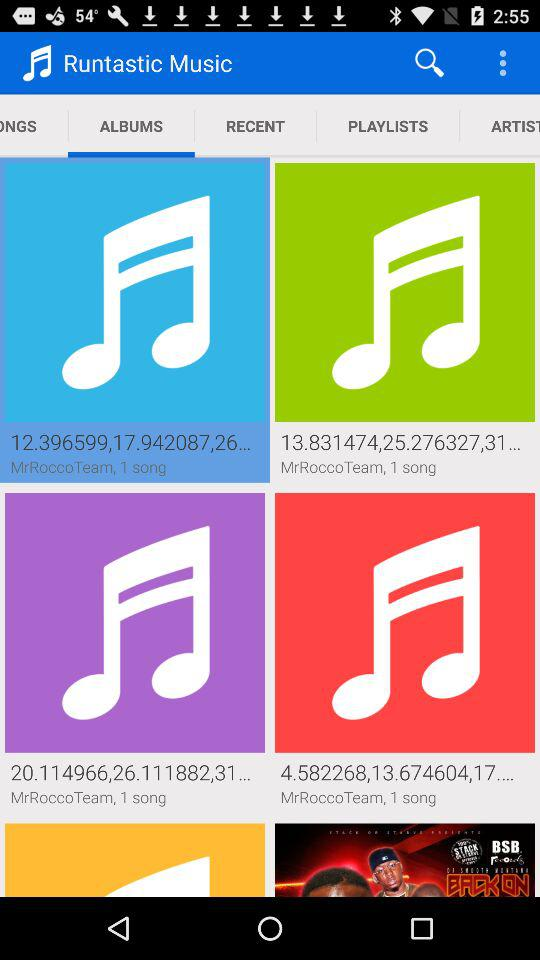Which tab is selected? The selected tab is "ALBUMS". 